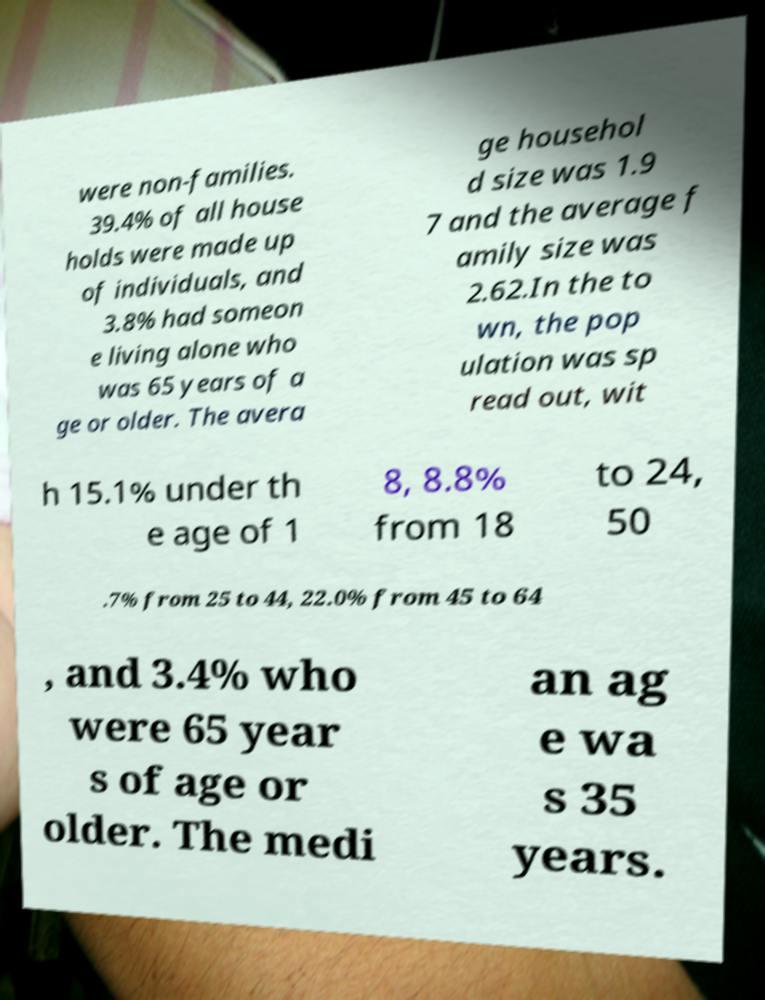Can you accurately transcribe the text from the provided image for me? were non-families. 39.4% of all house holds were made up of individuals, and 3.8% had someon e living alone who was 65 years of a ge or older. The avera ge househol d size was 1.9 7 and the average f amily size was 2.62.In the to wn, the pop ulation was sp read out, wit h 15.1% under th e age of 1 8, 8.8% from 18 to 24, 50 .7% from 25 to 44, 22.0% from 45 to 64 , and 3.4% who were 65 year s of age or older. The medi an ag e wa s 35 years. 